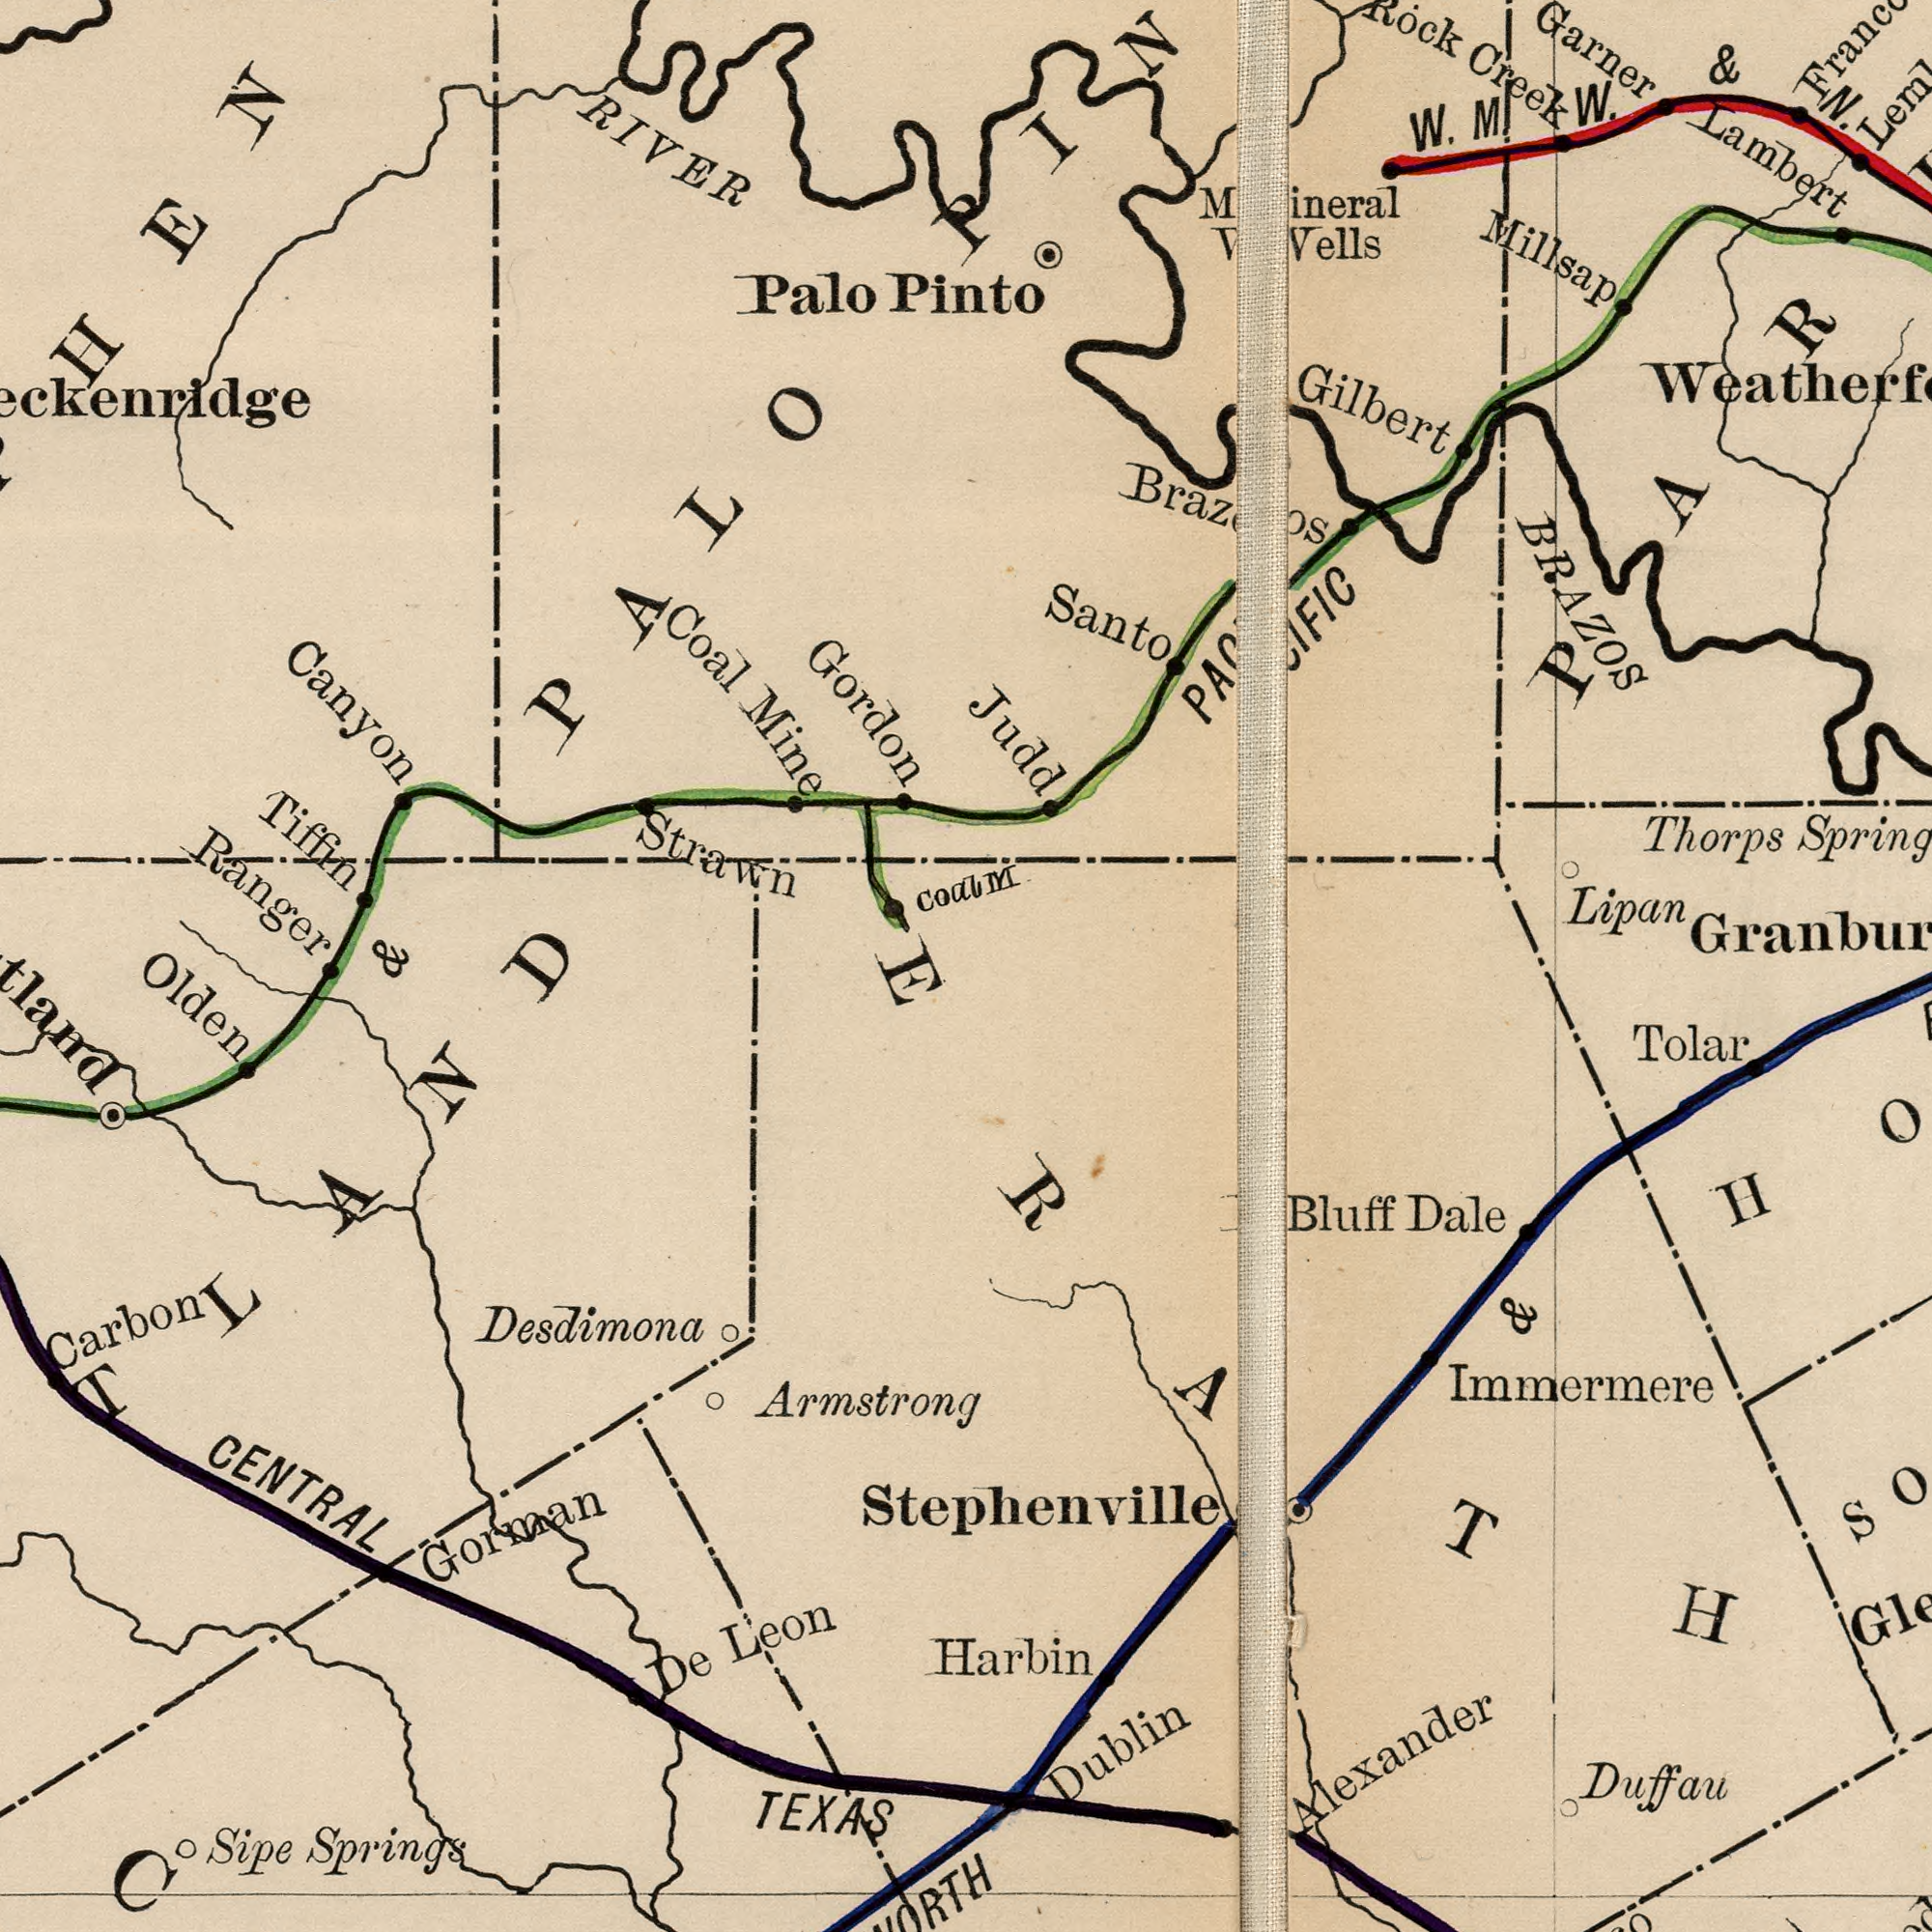What text is visible in the lower-right corner? Alexander Bluff Dale Tolar Dublin Harbin Immermere Duffau & Stephenville ERATH What text is visible in the upper-left corner? Gordon Ranger Canyon Strawn Tiffin Palo Pinto Coal Mine RIVER Coal PALO What text is shown in the top-right quadrant? M BRAZOS Lambert Gilbert Millsap W. M W. & N. Rock Creek Santo Lipan Thorps Spring Mineral Wells Judd Garner What text is shown in the bottom-left quadrant? Desdimona CENTRAL Gorman Carbon Sipe Springs De Leon TEXAS Armstrong Olden & ###TLAND 